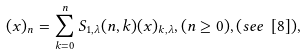<formula> <loc_0><loc_0><loc_500><loc_500>( x ) _ { n } = \sum _ { k = 0 } ^ { n } S _ { 1 , \lambda } ( n , k ) ( x ) _ { k , \lambda } , ( n \geq 0 ) , ( s e e \ [ 8 ] ) ,</formula> 